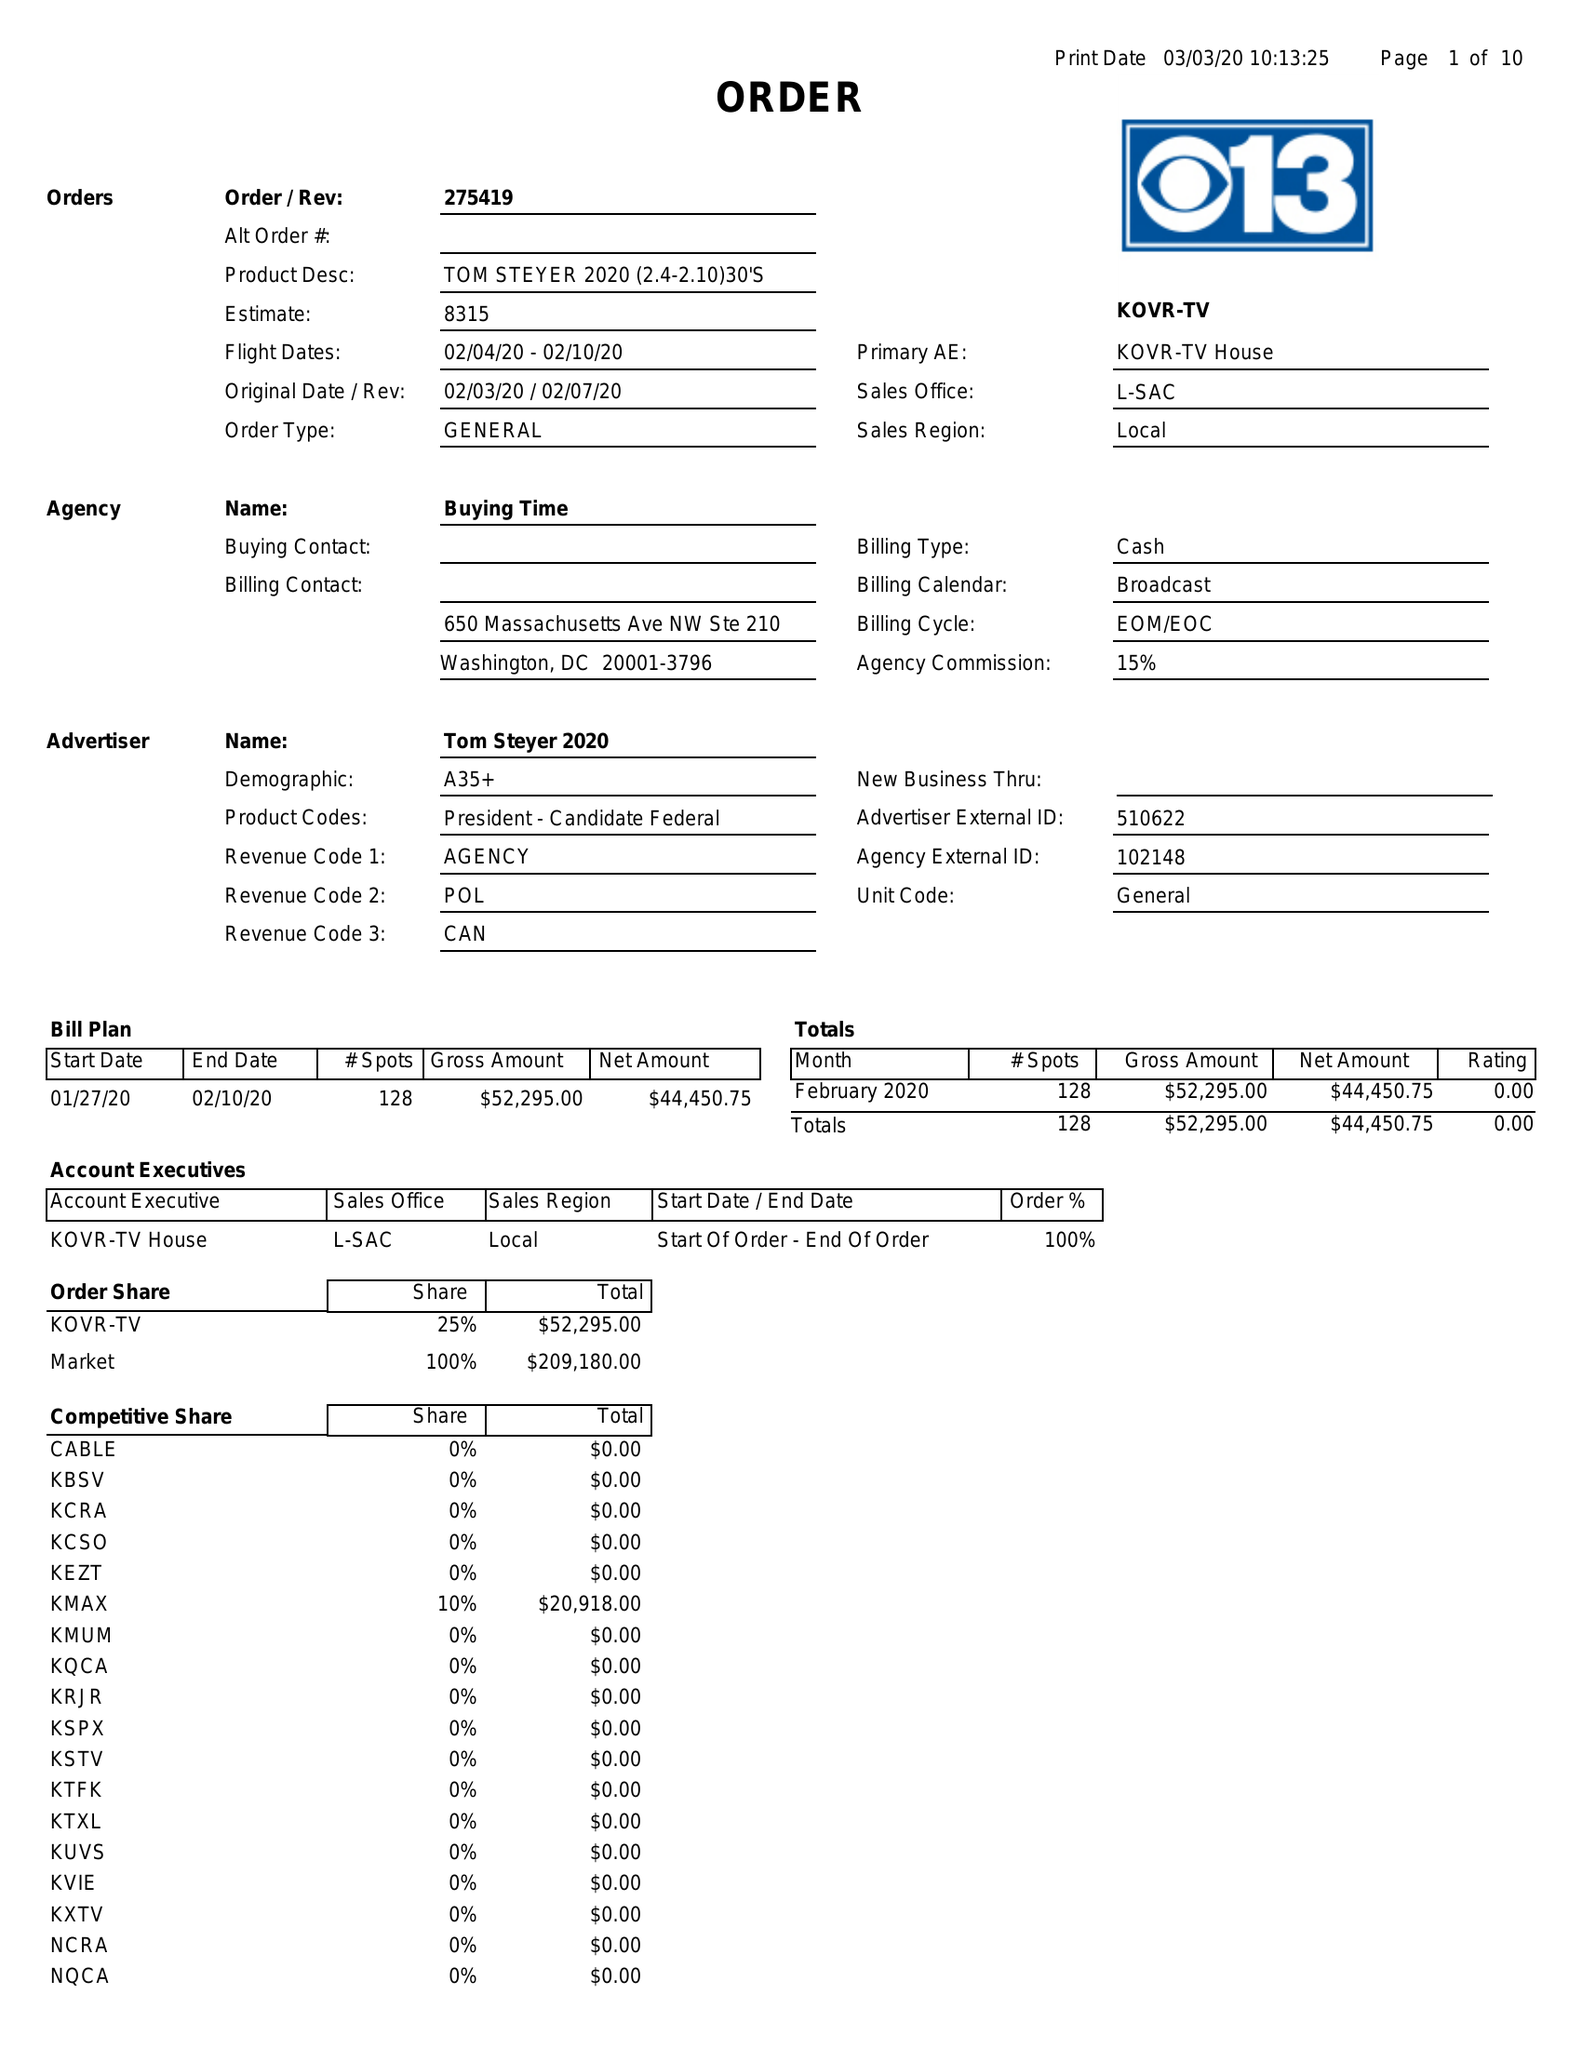What is the value for the flight_from?
Answer the question using a single word or phrase. 02/04/20 